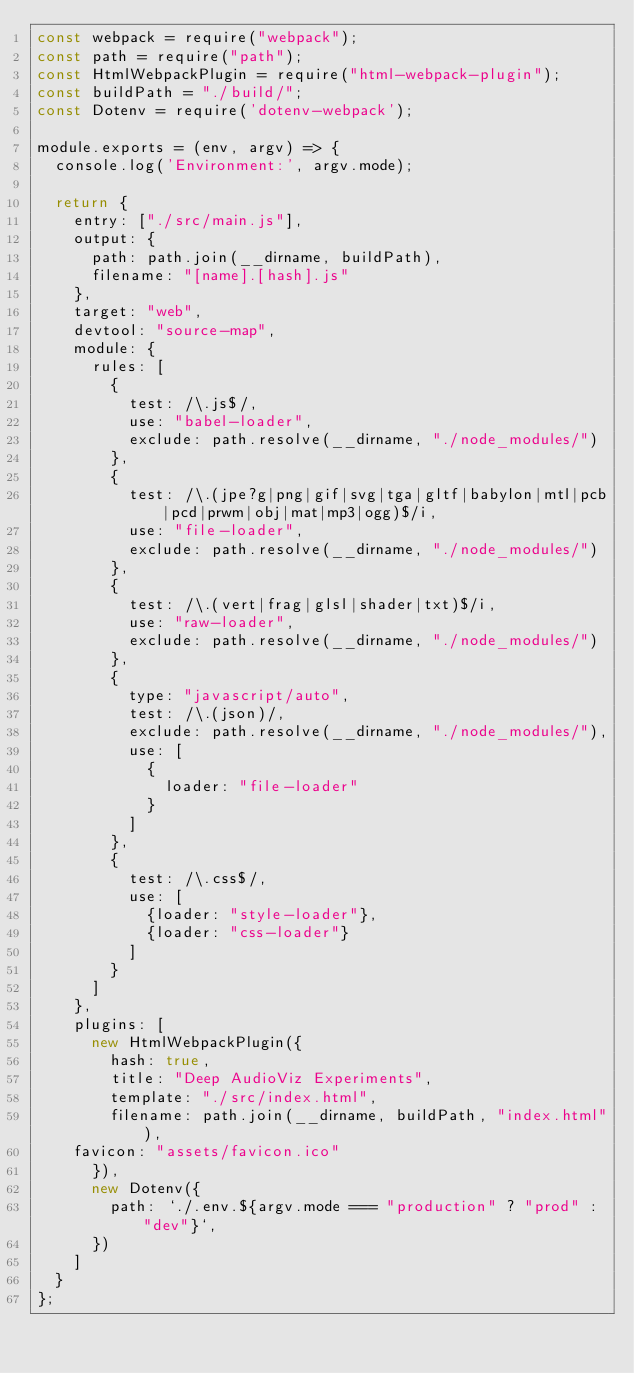<code> <loc_0><loc_0><loc_500><loc_500><_JavaScript_>const webpack = require("webpack");
const path = require("path");
const HtmlWebpackPlugin = require("html-webpack-plugin");
const buildPath = "./build/";
const Dotenv = require('dotenv-webpack');

module.exports = (env, argv) => {
  console.log('Environment:', argv.mode);

  return {
    entry: ["./src/main.js"],
    output: {
      path: path.join(__dirname, buildPath),
      filename: "[name].[hash].js"
    },
    target: "web",
    devtool: "source-map",
    module: {
      rules: [
        {
          test: /\.js$/,
          use: "babel-loader",
          exclude: path.resolve(__dirname, "./node_modules/")
        },
        {
          test: /\.(jpe?g|png|gif|svg|tga|gltf|babylon|mtl|pcb|pcd|prwm|obj|mat|mp3|ogg)$/i,
          use: "file-loader",
          exclude: path.resolve(__dirname, "./node_modules/")
        },
        {
          test: /\.(vert|frag|glsl|shader|txt)$/i,
          use: "raw-loader",
          exclude: path.resolve(__dirname, "./node_modules/")
        },
        {
          type: "javascript/auto",
          test: /\.(json)/,
          exclude: path.resolve(__dirname, "./node_modules/"),
          use: [
            {
              loader: "file-loader"
            }
          ]
        },
        {
          test: /\.css$/,
          use: [
            {loader: "style-loader"},
            {loader: "css-loader"}
          ]
        }
      ]
    },
    plugins: [
      new HtmlWebpackPlugin({
        hash: true,
        title: "Deep AudioViz Experiments",
        template: "./src/index.html",
        filename: path.join(__dirname, buildPath, "index.html"),
	favicon: "assets/favicon.ico"
      }),
      new Dotenv({
        path: `./.env.${argv.mode === "production" ? "prod" : "dev"}`,
      })
    ]
  }
};
</code> 